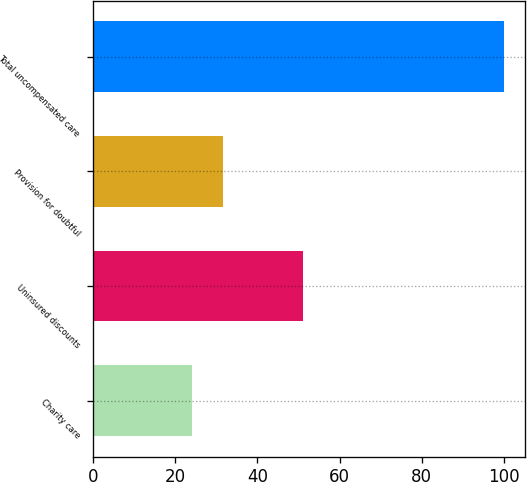<chart> <loc_0><loc_0><loc_500><loc_500><bar_chart><fcel>Charity care<fcel>Uninsured discounts<fcel>Provision for doubtful<fcel>Total uncompensated care<nl><fcel>24<fcel>51<fcel>31.6<fcel>100<nl></chart> 